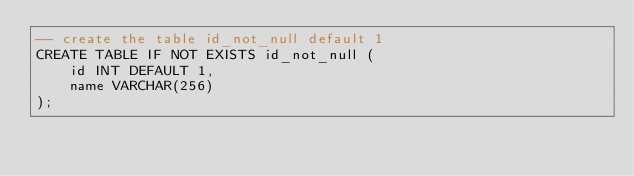<code> <loc_0><loc_0><loc_500><loc_500><_SQL_>-- create the table id_not_null default 1
CREATE TABLE IF NOT EXISTS id_not_null (
    id INT DEFAULT 1,
    name VARCHAR(256)
);
</code> 